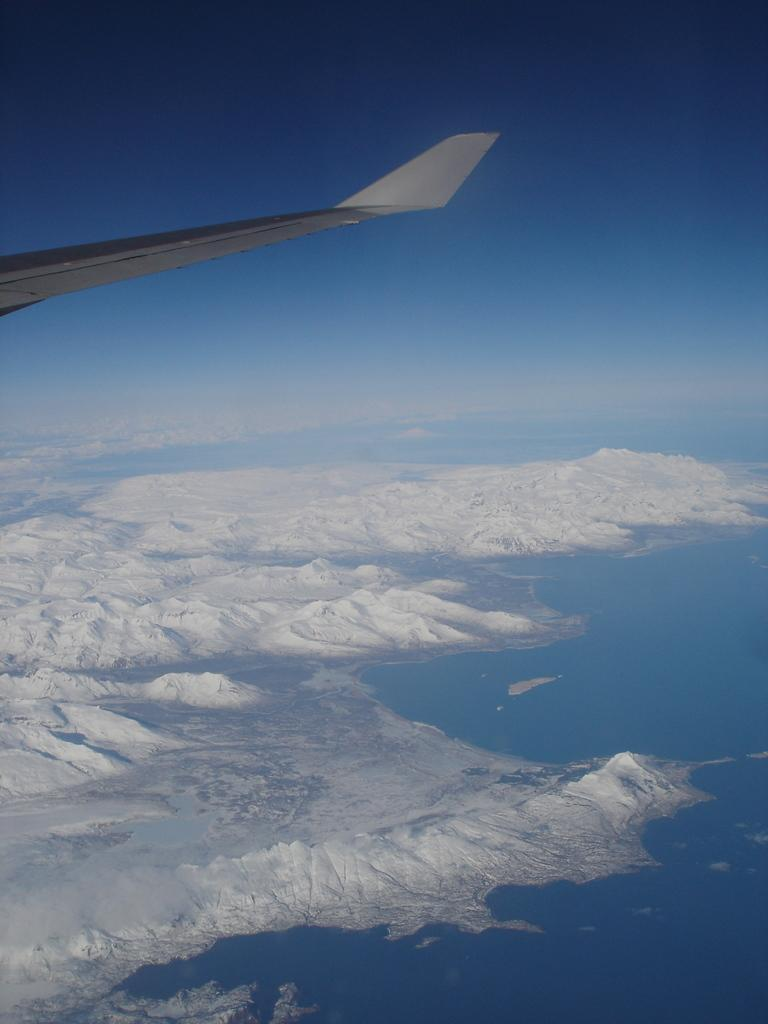What is the main subject of the image? The main subject of the image is a flying jet. What part of the jet can be seen in the image? The wing of the jet is visible in the image. What type of weather is depicted in the image? There is snow and water in the image, suggesting a wintry scene. What is visible in the background of the image? The sky is visible in the image. Who is the creator of the toy jet in the image? There is no toy jet present in the image; it features a real flying jet. What type of liquid is being poured from the jet in the image? There is no liquid being poured from the jet in the image; it is flying through the air. 